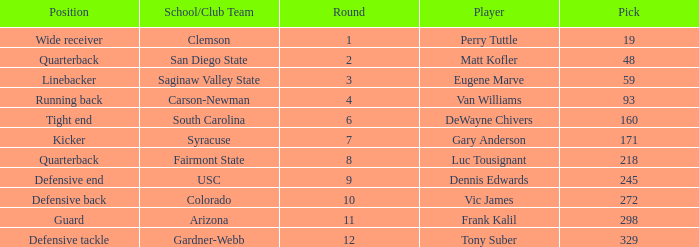Which Round has a School/Club Team of arizona, and a Pick smaller than 298? None. Help me parse the entirety of this table. {'header': ['Position', 'School/Club Team', 'Round', 'Player', 'Pick'], 'rows': [['Wide receiver', 'Clemson', '1', 'Perry Tuttle', '19'], ['Quarterback', 'San Diego State', '2', 'Matt Kofler', '48'], ['Linebacker', 'Saginaw Valley State', '3', 'Eugene Marve', '59'], ['Running back', 'Carson-Newman', '4', 'Van Williams', '93'], ['Tight end', 'South Carolina', '6', 'DeWayne Chivers', '160'], ['Kicker', 'Syracuse', '7', 'Gary Anderson', '171'], ['Quarterback', 'Fairmont State', '8', 'Luc Tousignant', '218'], ['Defensive end', 'USC', '9', 'Dennis Edwards', '245'], ['Defensive back', 'Colorado', '10', 'Vic James', '272'], ['Guard', 'Arizona', '11', 'Frank Kalil', '298'], ['Defensive tackle', 'Gardner-Webb', '12', 'Tony Suber', '329']]} 